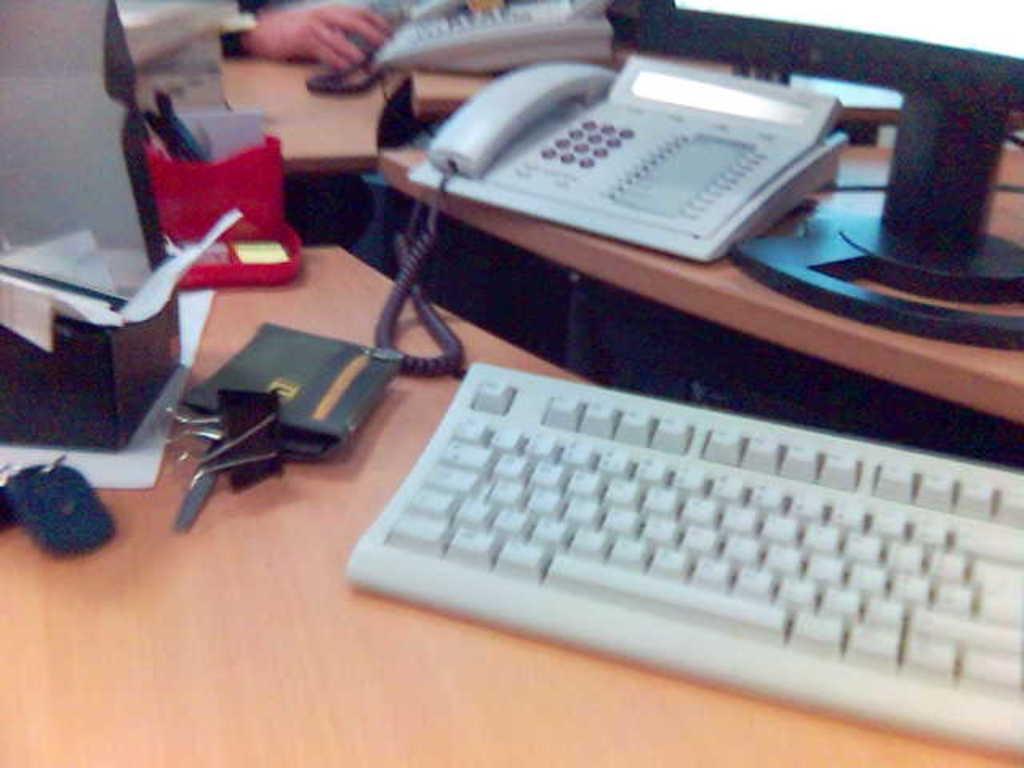Please provide a concise description of this image. In this image i can see a key board,purse , few papers, a telephone, pens a human hand a desk top on a table. 